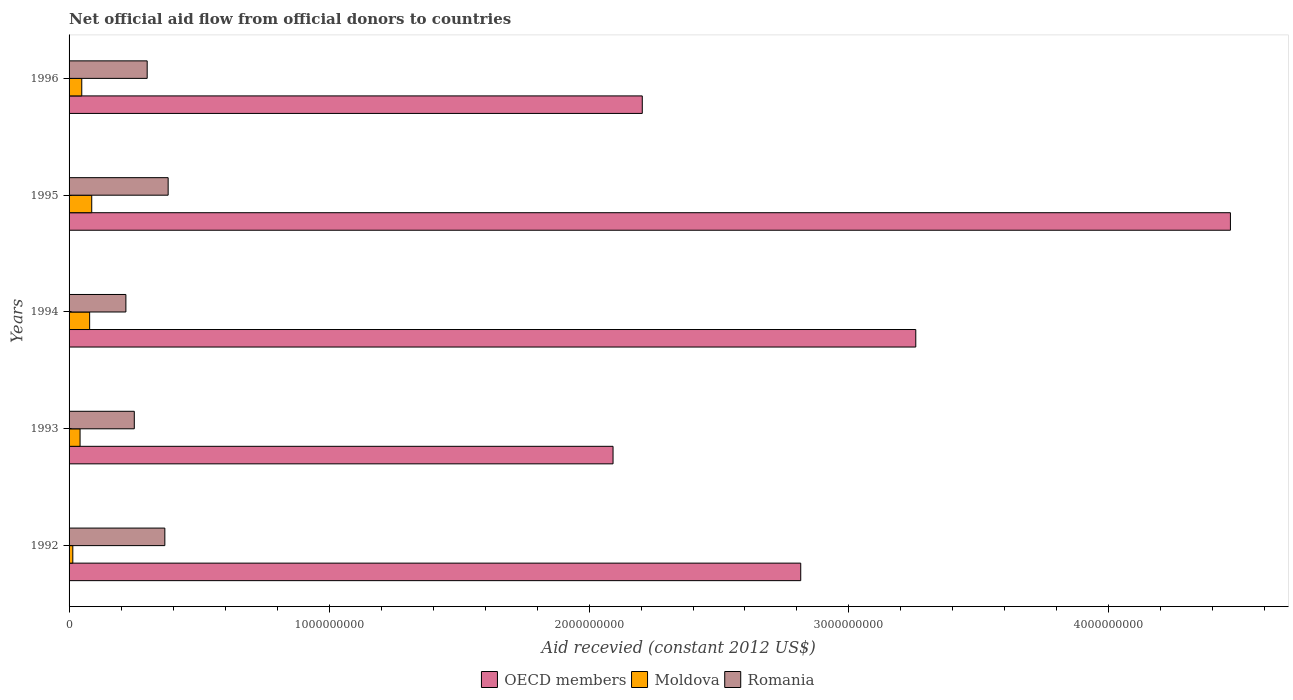How many groups of bars are there?
Your answer should be compact. 5. Are the number of bars per tick equal to the number of legend labels?
Offer a very short reply. Yes. Are the number of bars on each tick of the Y-axis equal?
Your answer should be compact. Yes. How many bars are there on the 4th tick from the top?
Keep it short and to the point. 3. How many bars are there on the 3rd tick from the bottom?
Ensure brevity in your answer.  3. In how many cases, is the number of bars for a given year not equal to the number of legend labels?
Offer a terse response. 0. What is the total aid received in Moldova in 1995?
Offer a terse response. 8.72e+07. Across all years, what is the maximum total aid received in OECD members?
Provide a succinct answer. 4.47e+09. Across all years, what is the minimum total aid received in Moldova?
Make the answer very short. 1.44e+07. What is the total total aid received in Romania in the graph?
Offer a terse response. 1.52e+09. What is the difference between the total aid received in Moldova in 1993 and that in 1996?
Make the answer very short. -6.56e+06. What is the difference between the total aid received in OECD members in 1994 and the total aid received in Romania in 1993?
Ensure brevity in your answer.  3.01e+09. What is the average total aid received in Romania per year?
Give a very brief answer. 3.04e+08. In the year 1996, what is the difference between the total aid received in Moldova and total aid received in OECD members?
Give a very brief answer. -2.16e+09. What is the ratio of the total aid received in OECD members in 1993 to that in 1995?
Your response must be concise. 0.47. Is the total aid received in OECD members in 1992 less than that in 1995?
Provide a short and direct response. Yes. What is the difference between the highest and the second highest total aid received in Romania?
Provide a short and direct response. 1.27e+07. What is the difference between the highest and the lowest total aid received in OECD members?
Your answer should be very brief. 2.37e+09. What does the 2nd bar from the top in 1993 represents?
Offer a very short reply. Moldova. What does the 1st bar from the bottom in 1992 represents?
Offer a very short reply. OECD members. Is it the case that in every year, the sum of the total aid received in Moldova and total aid received in Romania is greater than the total aid received in OECD members?
Make the answer very short. No. How many bars are there?
Keep it short and to the point. 15. How many years are there in the graph?
Your response must be concise. 5. How many legend labels are there?
Offer a terse response. 3. How are the legend labels stacked?
Offer a terse response. Horizontal. What is the title of the graph?
Give a very brief answer. Net official aid flow from official donors to countries. Does "Sub-Saharan Africa (developing only)" appear as one of the legend labels in the graph?
Offer a very short reply. No. What is the label or title of the X-axis?
Your response must be concise. Aid recevied (constant 2012 US$). What is the Aid recevied (constant 2012 US$) in OECD members in 1992?
Keep it short and to the point. 2.81e+09. What is the Aid recevied (constant 2012 US$) of Moldova in 1992?
Keep it short and to the point. 1.44e+07. What is the Aid recevied (constant 2012 US$) in Romania in 1992?
Offer a terse response. 3.68e+08. What is the Aid recevied (constant 2012 US$) of OECD members in 1993?
Offer a terse response. 2.09e+09. What is the Aid recevied (constant 2012 US$) in Moldova in 1993?
Give a very brief answer. 4.23e+07. What is the Aid recevied (constant 2012 US$) of Romania in 1993?
Your answer should be very brief. 2.51e+08. What is the Aid recevied (constant 2012 US$) in OECD members in 1994?
Offer a terse response. 3.26e+09. What is the Aid recevied (constant 2012 US$) of Moldova in 1994?
Your answer should be very brief. 7.92e+07. What is the Aid recevied (constant 2012 US$) in Romania in 1994?
Provide a succinct answer. 2.19e+08. What is the Aid recevied (constant 2012 US$) in OECD members in 1995?
Keep it short and to the point. 4.47e+09. What is the Aid recevied (constant 2012 US$) of Moldova in 1995?
Keep it short and to the point. 8.72e+07. What is the Aid recevied (constant 2012 US$) in Romania in 1995?
Your response must be concise. 3.81e+08. What is the Aid recevied (constant 2012 US$) of OECD members in 1996?
Make the answer very short. 2.20e+09. What is the Aid recevied (constant 2012 US$) in Moldova in 1996?
Your answer should be compact. 4.89e+07. What is the Aid recevied (constant 2012 US$) of Romania in 1996?
Give a very brief answer. 3.00e+08. Across all years, what is the maximum Aid recevied (constant 2012 US$) in OECD members?
Offer a very short reply. 4.47e+09. Across all years, what is the maximum Aid recevied (constant 2012 US$) in Moldova?
Your response must be concise. 8.72e+07. Across all years, what is the maximum Aid recevied (constant 2012 US$) of Romania?
Your response must be concise. 3.81e+08. Across all years, what is the minimum Aid recevied (constant 2012 US$) of OECD members?
Make the answer very short. 2.09e+09. Across all years, what is the minimum Aid recevied (constant 2012 US$) of Moldova?
Your response must be concise. 1.44e+07. Across all years, what is the minimum Aid recevied (constant 2012 US$) of Romania?
Make the answer very short. 2.19e+08. What is the total Aid recevied (constant 2012 US$) of OECD members in the graph?
Ensure brevity in your answer.  1.48e+1. What is the total Aid recevied (constant 2012 US$) in Moldova in the graph?
Make the answer very short. 2.72e+08. What is the total Aid recevied (constant 2012 US$) in Romania in the graph?
Provide a short and direct response. 1.52e+09. What is the difference between the Aid recevied (constant 2012 US$) of OECD members in 1992 and that in 1993?
Provide a succinct answer. 7.22e+08. What is the difference between the Aid recevied (constant 2012 US$) of Moldova in 1992 and that in 1993?
Offer a terse response. -2.79e+07. What is the difference between the Aid recevied (constant 2012 US$) of Romania in 1992 and that in 1993?
Offer a terse response. 1.18e+08. What is the difference between the Aid recevied (constant 2012 US$) in OECD members in 1992 and that in 1994?
Your response must be concise. -4.43e+08. What is the difference between the Aid recevied (constant 2012 US$) in Moldova in 1992 and that in 1994?
Keep it short and to the point. -6.47e+07. What is the difference between the Aid recevied (constant 2012 US$) of Romania in 1992 and that in 1994?
Provide a succinct answer. 1.50e+08. What is the difference between the Aid recevied (constant 2012 US$) of OECD members in 1992 and that in 1995?
Your answer should be very brief. -1.65e+09. What is the difference between the Aid recevied (constant 2012 US$) in Moldova in 1992 and that in 1995?
Ensure brevity in your answer.  -7.27e+07. What is the difference between the Aid recevied (constant 2012 US$) of Romania in 1992 and that in 1995?
Provide a succinct answer. -1.27e+07. What is the difference between the Aid recevied (constant 2012 US$) in OECD members in 1992 and that in 1996?
Ensure brevity in your answer.  6.09e+08. What is the difference between the Aid recevied (constant 2012 US$) of Moldova in 1992 and that in 1996?
Your answer should be very brief. -3.44e+07. What is the difference between the Aid recevied (constant 2012 US$) of Romania in 1992 and that in 1996?
Offer a terse response. 6.80e+07. What is the difference between the Aid recevied (constant 2012 US$) of OECD members in 1993 and that in 1994?
Your answer should be very brief. -1.16e+09. What is the difference between the Aid recevied (constant 2012 US$) in Moldova in 1993 and that in 1994?
Your answer should be compact. -3.68e+07. What is the difference between the Aid recevied (constant 2012 US$) of Romania in 1993 and that in 1994?
Offer a very short reply. 3.24e+07. What is the difference between the Aid recevied (constant 2012 US$) in OECD members in 1993 and that in 1995?
Give a very brief answer. -2.37e+09. What is the difference between the Aid recevied (constant 2012 US$) in Moldova in 1993 and that in 1995?
Make the answer very short. -4.48e+07. What is the difference between the Aid recevied (constant 2012 US$) of Romania in 1993 and that in 1995?
Provide a succinct answer. -1.30e+08. What is the difference between the Aid recevied (constant 2012 US$) of OECD members in 1993 and that in 1996?
Ensure brevity in your answer.  -1.12e+08. What is the difference between the Aid recevied (constant 2012 US$) of Moldova in 1993 and that in 1996?
Your answer should be very brief. -6.56e+06. What is the difference between the Aid recevied (constant 2012 US$) in Romania in 1993 and that in 1996?
Ensure brevity in your answer.  -4.95e+07. What is the difference between the Aid recevied (constant 2012 US$) of OECD members in 1994 and that in 1995?
Provide a short and direct response. -1.21e+09. What is the difference between the Aid recevied (constant 2012 US$) of Moldova in 1994 and that in 1995?
Provide a short and direct response. -8.00e+06. What is the difference between the Aid recevied (constant 2012 US$) of Romania in 1994 and that in 1995?
Provide a short and direct response. -1.63e+08. What is the difference between the Aid recevied (constant 2012 US$) in OECD members in 1994 and that in 1996?
Offer a terse response. 1.05e+09. What is the difference between the Aid recevied (constant 2012 US$) in Moldova in 1994 and that in 1996?
Your response must be concise. 3.03e+07. What is the difference between the Aid recevied (constant 2012 US$) in Romania in 1994 and that in 1996?
Make the answer very short. -8.19e+07. What is the difference between the Aid recevied (constant 2012 US$) in OECD members in 1995 and that in 1996?
Offer a very short reply. 2.26e+09. What is the difference between the Aid recevied (constant 2012 US$) in Moldova in 1995 and that in 1996?
Your answer should be compact. 3.83e+07. What is the difference between the Aid recevied (constant 2012 US$) of Romania in 1995 and that in 1996?
Ensure brevity in your answer.  8.07e+07. What is the difference between the Aid recevied (constant 2012 US$) of OECD members in 1992 and the Aid recevied (constant 2012 US$) of Moldova in 1993?
Your response must be concise. 2.77e+09. What is the difference between the Aid recevied (constant 2012 US$) in OECD members in 1992 and the Aid recevied (constant 2012 US$) in Romania in 1993?
Your response must be concise. 2.56e+09. What is the difference between the Aid recevied (constant 2012 US$) in Moldova in 1992 and the Aid recevied (constant 2012 US$) in Romania in 1993?
Offer a very short reply. -2.36e+08. What is the difference between the Aid recevied (constant 2012 US$) of OECD members in 1992 and the Aid recevied (constant 2012 US$) of Moldova in 1994?
Your response must be concise. 2.74e+09. What is the difference between the Aid recevied (constant 2012 US$) in OECD members in 1992 and the Aid recevied (constant 2012 US$) in Romania in 1994?
Ensure brevity in your answer.  2.60e+09. What is the difference between the Aid recevied (constant 2012 US$) of Moldova in 1992 and the Aid recevied (constant 2012 US$) of Romania in 1994?
Your answer should be very brief. -2.04e+08. What is the difference between the Aid recevied (constant 2012 US$) in OECD members in 1992 and the Aid recevied (constant 2012 US$) in Moldova in 1995?
Ensure brevity in your answer.  2.73e+09. What is the difference between the Aid recevied (constant 2012 US$) in OECD members in 1992 and the Aid recevied (constant 2012 US$) in Romania in 1995?
Make the answer very short. 2.43e+09. What is the difference between the Aid recevied (constant 2012 US$) of Moldova in 1992 and the Aid recevied (constant 2012 US$) of Romania in 1995?
Your answer should be compact. -3.67e+08. What is the difference between the Aid recevied (constant 2012 US$) of OECD members in 1992 and the Aid recevied (constant 2012 US$) of Moldova in 1996?
Your response must be concise. 2.77e+09. What is the difference between the Aid recevied (constant 2012 US$) of OECD members in 1992 and the Aid recevied (constant 2012 US$) of Romania in 1996?
Offer a very short reply. 2.51e+09. What is the difference between the Aid recevied (constant 2012 US$) of Moldova in 1992 and the Aid recevied (constant 2012 US$) of Romania in 1996?
Keep it short and to the point. -2.86e+08. What is the difference between the Aid recevied (constant 2012 US$) in OECD members in 1993 and the Aid recevied (constant 2012 US$) in Moldova in 1994?
Offer a very short reply. 2.01e+09. What is the difference between the Aid recevied (constant 2012 US$) in OECD members in 1993 and the Aid recevied (constant 2012 US$) in Romania in 1994?
Keep it short and to the point. 1.87e+09. What is the difference between the Aid recevied (constant 2012 US$) of Moldova in 1993 and the Aid recevied (constant 2012 US$) of Romania in 1994?
Your answer should be very brief. -1.76e+08. What is the difference between the Aid recevied (constant 2012 US$) of OECD members in 1993 and the Aid recevied (constant 2012 US$) of Moldova in 1995?
Offer a very short reply. 2.01e+09. What is the difference between the Aid recevied (constant 2012 US$) in OECD members in 1993 and the Aid recevied (constant 2012 US$) in Romania in 1995?
Make the answer very short. 1.71e+09. What is the difference between the Aid recevied (constant 2012 US$) of Moldova in 1993 and the Aid recevied (constant 2012 US$) of Romania in 1995?
Keep it short and to the point. -3.39e+08. What is the difference between the Aid recevied (constant 2012 US$) of OECD members in 1993 and the Aid recevied (constant 2012 US$) of Moldova in 1996?
Give a very brief answer. 2.04e+09. What is the difference between the Aid recevied (constant 2012 US$) in OECD members in 1993 and the Aid recevied (constant 2012 US$) in Romania in 1996?
Offer a very short reply. 1.79e+09. What is the difference between the Aid recevied (constant 2012 US$) in Moldova in 1993 and the Aid recevied (constant 2012 US$) in Romania in 1996?
Your response must be concise. -2.58e+08. What is the difference between the Aid recevied (constant 2012 US$) in OECD members in 1994 and the Aid recevied (constant 2012 US$) in Moldova in 1995?
Your answer should be compact. 3.17e+09. What is the difference between the Aid recevied (constant 2012 US$) in OECD members in 1994 and the Aid recevied (constant 2012 US$) in Romania in 1995?
Keep it short and to the point. 2.88e+09. What is the difference between the Aid recevied (constant 2012 US$) of Moldova in 1994 and the Aid recevied (constant 2012 US$) of Romania in 1995?
Keep it short and to the point. -3.02e+08. What is the difference between the Aid recevied (constant 2012 US$) in OECD members in 1994 and the Aid recevied (constant 2012 US$) in Moldova in 1996?
Offer a very short reply. 3.21e+09. What is the difference between the Aid recevied (constant 2012 US$) of OECD members in 1994 and the Aid recevied (constant 2012 US$) of Romania in 1996?
Offer a very short reply. 2.96e+09. What is the difference between the Aid recevied (constant 2012 US$) in Moldova in 1994 and the Aid recevied (constant 2012 US$) in Romania in 1996?
Offer a terse response. -2.21e+08. What is the difference between the Aid recevied (constant 2012 US$) of OECD members in 1995 and the Aid recevied (constant 2012 US$) of Moldova in 1996?
Your answer should be compact. 4.42e+09. What is the difference between the Aid recevied (constant 2012 US$) in OECD members in 1995 and the Aid recevied (constant 2012 US$) in Romania in 1996?
Your answer should be very brief. 4.17e+09. What is the difference between the Aid recevied (constant 2012 US$) of Moldova in 1995 and the Aid recevied (constant 2012 US$) of Romania in 1996?
Make the answer very short. -2.13e+08. What is the average Aid recevied (constant 2012 US$) of OECD members per year?
Provide a short and direct response. 2.97e+09. What is the average Aid recevied (constant 2012 US$) in Moldova per year?
Make the answer very short. 5.44e+07. What is the average Aid recevied (constant 2012 US$) in Romania per year?
Offer a terse response. 3.04e+08. In the year 1992, what is the difference between the Aid recevied (constant 2012 US$) in OECD members and Aid recevied (constant 2012 US$) in Moldova?
Your answer should be compact. 2.80e+09. In the year 1992, what is the difference between the Aid recevied (constant 2012 US$) of OECD members and Aid recevied (constant 2012 US$) of Romania?
Offer a terse response. 2.45e+09. In the year 1992, what is the difference between the Aid recevied (constant 2012 US$) of Moldova and Aid recevied (constant 2012 US$) of Romania?
Keep it short and to the point. -3.54e+08. In the year 1993, what is the difference between the Aid recevied (constant 2012 US$) in OECD members and Aid recevied (constant 2012 US$) in Moldova?
Provide a succinct answer. 2.05e+09. In the year 1993, what is the difference between the Aid recevied (constant 2012 US$) in OECD members and Aid recevied (constant 2012 US$) in Romania?
Your answer should be compact. 1.84e+09. In the year 1993, what is the difference between the Aid recevied (constant 2012 US$) of Moldova and Aid recevied (constant 2012 US$) of Romania?
Offer a very short reply. -2.09e+08. In the year 1994, what is the difference between the Aid recevied (constant 2012 US$) of OECD members and Aid recevied (constant 2012 US$) of Moldova?
Offer a very short reply. 3.18e+09. In the year 1994, what is the difference between the Aid recevied (constant 2012 US$) of OECD members and Aid recevied (constant 2012 US$) of Romania?
Ensure brevity in your answer.  3.04e+09. In the year 1994, what is the difference between the Aid recevied (constant 2012 US$) of Moldova and Aid recevied (constant 2012 US$) of Romania?
Your answer should be compact. -1.39e+08. In the year 1995, what is the difference between the Aid recevied (constant 2012 US$) in OECD members and Aid recevied (constant 2012 US$) in Moldova?
Make the answer very short. 4.38e+09. In the year 1995, what is the difference between the Aid recevied (constant 2012 US$) in OECD members and Aid recevied (constant 2012 US$) in Romania?
Provide a succinct answer. 4.09e+09. In the year 1995, what is the difference between the Aid recevied (constant 2012 US$) of Moldova and Aid recevied (constant 2012 US$) of Romania?
Provide a short and direct response. -2.94e+08. In the year 1996, what is the difference between the Aid recevied (constant 2012 US$) of OECD members and Aid recevied (constant 2012 US$) of Moldova?
Offer a terse response. 2.16e+09. In the year 1996, what is the difference between the Aid recevied (constant 2012 US$) in OECD members and Aid recevied (constant 2012 US$) in Romania?
Provide a succinct answer. 1.90e+09. In the year 1996, what is the difference between the Aid recevied (constant 2012 US$) of Moldova and Aid recevied (constant 2012 US$) of Romania?
Offer a terse response. -2.52e+08. What is the ratio of the Aid recevied (constant 2012 US$) of OECD members in 1992 to that in 1993?
Ensure brevity in your answer.  1.34. What is the ratio of the Aid recevied (constant 2012 US$) in Moldova in 1992 to that in 1993?
Give a very brief answer. 0.34. What is the ratio of the Aid recevied (constant 2012 US$) of Romania in 1992 to that in 1993?
Provide a short and direct response. 1.47. What is the ratio of the Aid recevied (constant 2012 US$) in OECD members in 1992 to that in 1994?
Offer a terse response. 0.86. What is the ratio of the Aid recevied (constant 2012 US$) in Moldova in 1992 to that in 1994?
Ensure brevity in your answer.  0.18. What is the ratio of the Aid recevied (constant 2012 US$) of Romania in 1992 to that in 1994?
Provide a short and direct response. 1.69. What is the ratio of the Aid recevied (constant 2012 US$) in OECD members in 1992 to that in 1995?
Provide a short and direct response. 0.63. What is the ratio of the Aid recevied (constant 2012 US$) of Moldova in 1992 to that in 1995?
Ensure brevity in your answer.  0.17. What is the ratio of the Aid recevied (constant 2012 US$) in Romania in 1992 to that in 1995?
Give a very brief answer. 0.97. What is the ratio of the Aid recevied (constant 2012 US$) of OECD members in 1992 to that in 1996?
Give a very brief answer. 1.28. What is the ratio of the Aid recevied (constant 2012 US$) of Moldova in 1992 to that in 1996?
Your response must be concise. 0.3. What is the ratio of the Aid recevied (constant 2012 US$) in Romania in 1992 to that in 1996?
Your answer should be compact. 1.23. What is the ratio of the Aid recevied (constant 2012 US$) of OECD members in 1993 to that in 1994?
Your answer should be compact. 0.64. What is the ratio of the Aid recevied (constant 2012 US$) of Moldova in 1993 to that in 1994?
Ensure brevity in your answer.  0.53. What is the ratio of the Aid recevied (constant 2012 US$) in Romania in 1993 to that in 1994?
Ensure brevity in your answer.  1.15. What is the ratio of the Aid recevied (constant 2012 US$) in OECD members in 1993 to that in 1995?
Ensure brevity in your answer.  0.47. What is the ratio of the Aid recevied (constant 2012 US$) in Moldova in 1993 to that in 1995?
Offer a terse response. 0.49. What is the ratio of the Aid recevied (constant 2012 US$) of Romania in 1993 to that in 1995?
Ensure brevity in your answer.  0.66. What is the ratio of the Aid recevied (constant 2012 US$) of OECD members in 1993 to that in 1996?
Provide a succinct answer. 0.95. What is the ratio of the Aid recevied (constant 2012 US$) in Moldova in 1993 to that in 1996?
Provide a short and direct response. 0.87. What is the ratio of the Aid recevied (constant 2012 US$) of Romania in 1993 to that in 1996?
Your answer should be very brief. 0.84. What is the ratio of the Aid recevied (constant 2012 US$) in OECD members in 1994 to that in 1995?
Your answer should be very brief. 0.73. What is the ratio of the Aid recevied (constant 2012 US$) in Moldova in 1994 to that in 1995?
Keep it short and to the point. 0.91. What is the ratio of the Aid recevied (constant 2012 US$) of Romania in 1994 to that in 1995?
Make the answer very short. 0.57. What is the ratio of the Aid recevied (constant 2012 US$) in OECD members in 1994 to that in 1996?
Give a very brief answer. 1.48. What is the ratio of the Aid recevied (constant 2012 US$) in Moldova in 1994 to that in 1996?
Provide a succinct answer. 1.62. What is the ratio of the Aid recevied (constant 2012 US$) in Romania in 1994 to that in 1996?
Provide a succinct answer. 0.73. What is the ratio of the Aid recevied (constant 2012 US$) in OECD members in 1995 to that in 1996?
Offer a terse response. 2.03. What is the ratio of the Aid recevied (constant 2012 US$) in Moldova in 1995 to that in 1996?
Keep it short and to the point. 1.78. What is the ratio of the Aid recevied (constant 2012 US$) of Romania in 1995 to that in 1996?
Offer a terse response. 1.27. What is the difference between the highest and the second highest Aid recevied (constant 2012 US$) in OECD members?
Provide a succinct answer. 1.21e+09. What is the difference between the highest and the second highest Aid recevied (constant 2012 US$) in Romania?
Ensure brevity in your answer.  1.27e+07. What is the difference between the highest and the lowest Aid recevied (constant 2012 US$) of OECD members?
Your answer should be very brief. 2.37e+09. What is the difference between the highest and the lowest Aid recevied (constant 2012 US$) of Moldova?
Your response must be concise. 7.27e+07. What is the difference between the highest and the lowest Aid recevied (constant 2012 US$) of Romania?
Make the answer very short. 1.63e+08. 